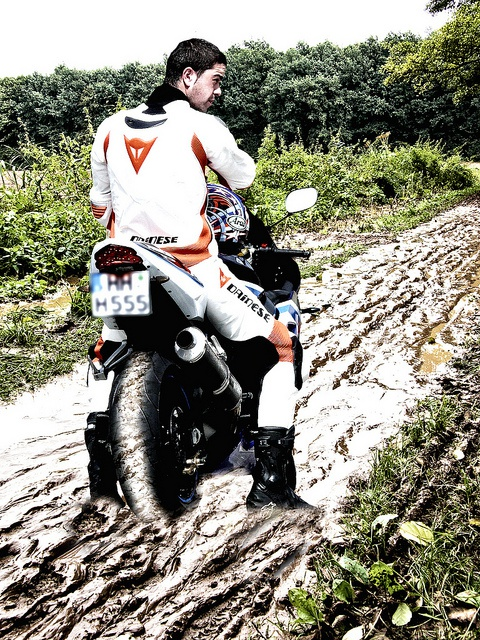Describe the objects in this image and their specific colors. I can see motorcycle in white, black, gray, and darkgray tones and people in white, black, gray, and darkgray tones in this image. 